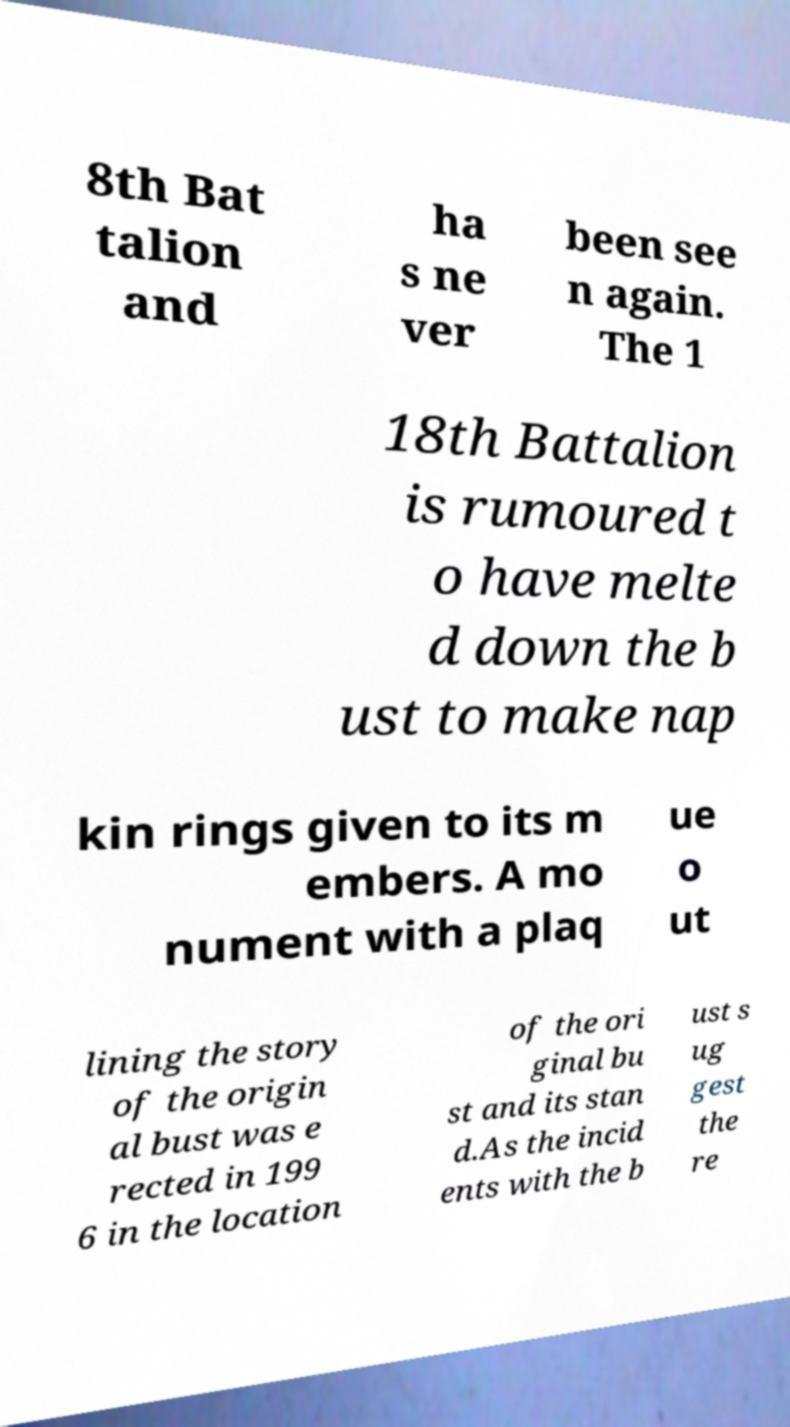Please identify and transcribe the text found in this image. 8th Bat talion and ha s ne ver been see n again. The 1 18th Battalion is rumoured t o have melte d down the b ust to make nap kin rings given to its m embers. A mo nument with a plaq ue o ut lining the story of the origin al bust was e rected in 199 6 in the location of the ori ginal bu st and its stan d.As the incid ents with the b ust s ug gest the re 